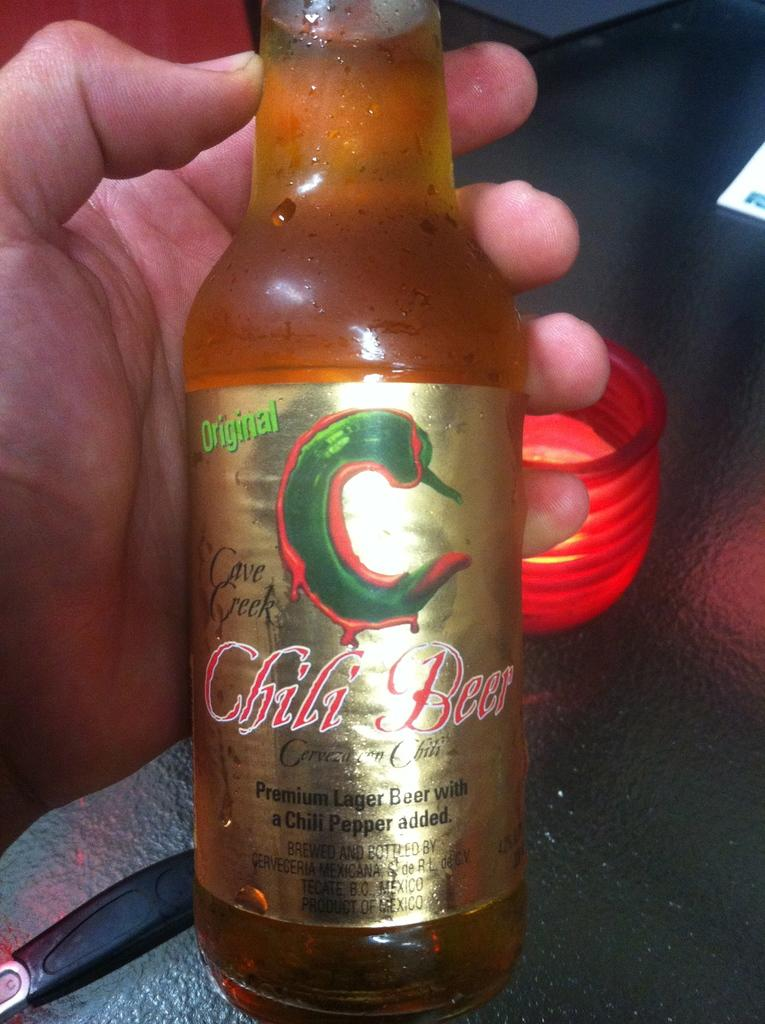<image>
Describe the image concisely. A hand holding a bottle of Chili Beer with a pepper pictured on it. 